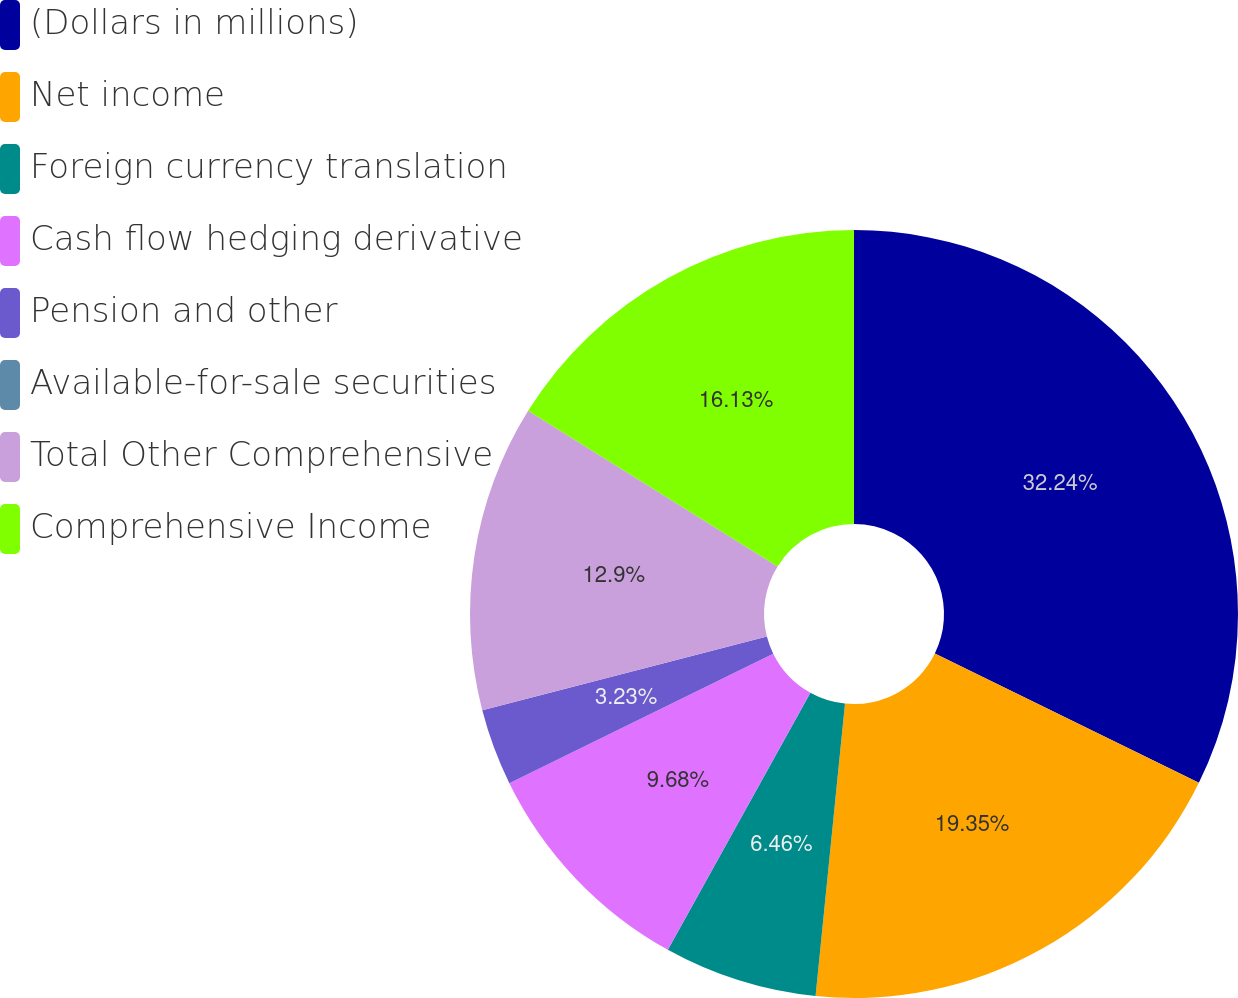Convert chart to OTSL. <chart><loc_0><loc_0><loc_500><loc_500><pie_chart><fcel>(Dollars in millions)<fcel>Net income<fcel>Foreign currency translation<fcel>Cash flow hedging derivative<fcel>Pension and other<fcel>Available-for-sale securities<fcel>Total Other Comprehensive<fcel>Comprehensive Income<nl><fcel>32.25%<fcel>19.35%<fcel>6.46%<fcel>9.68%<fcel>3.23%<fcel>0.01%<fcel>12.9%<fcel>16.13%<nl></chart> 